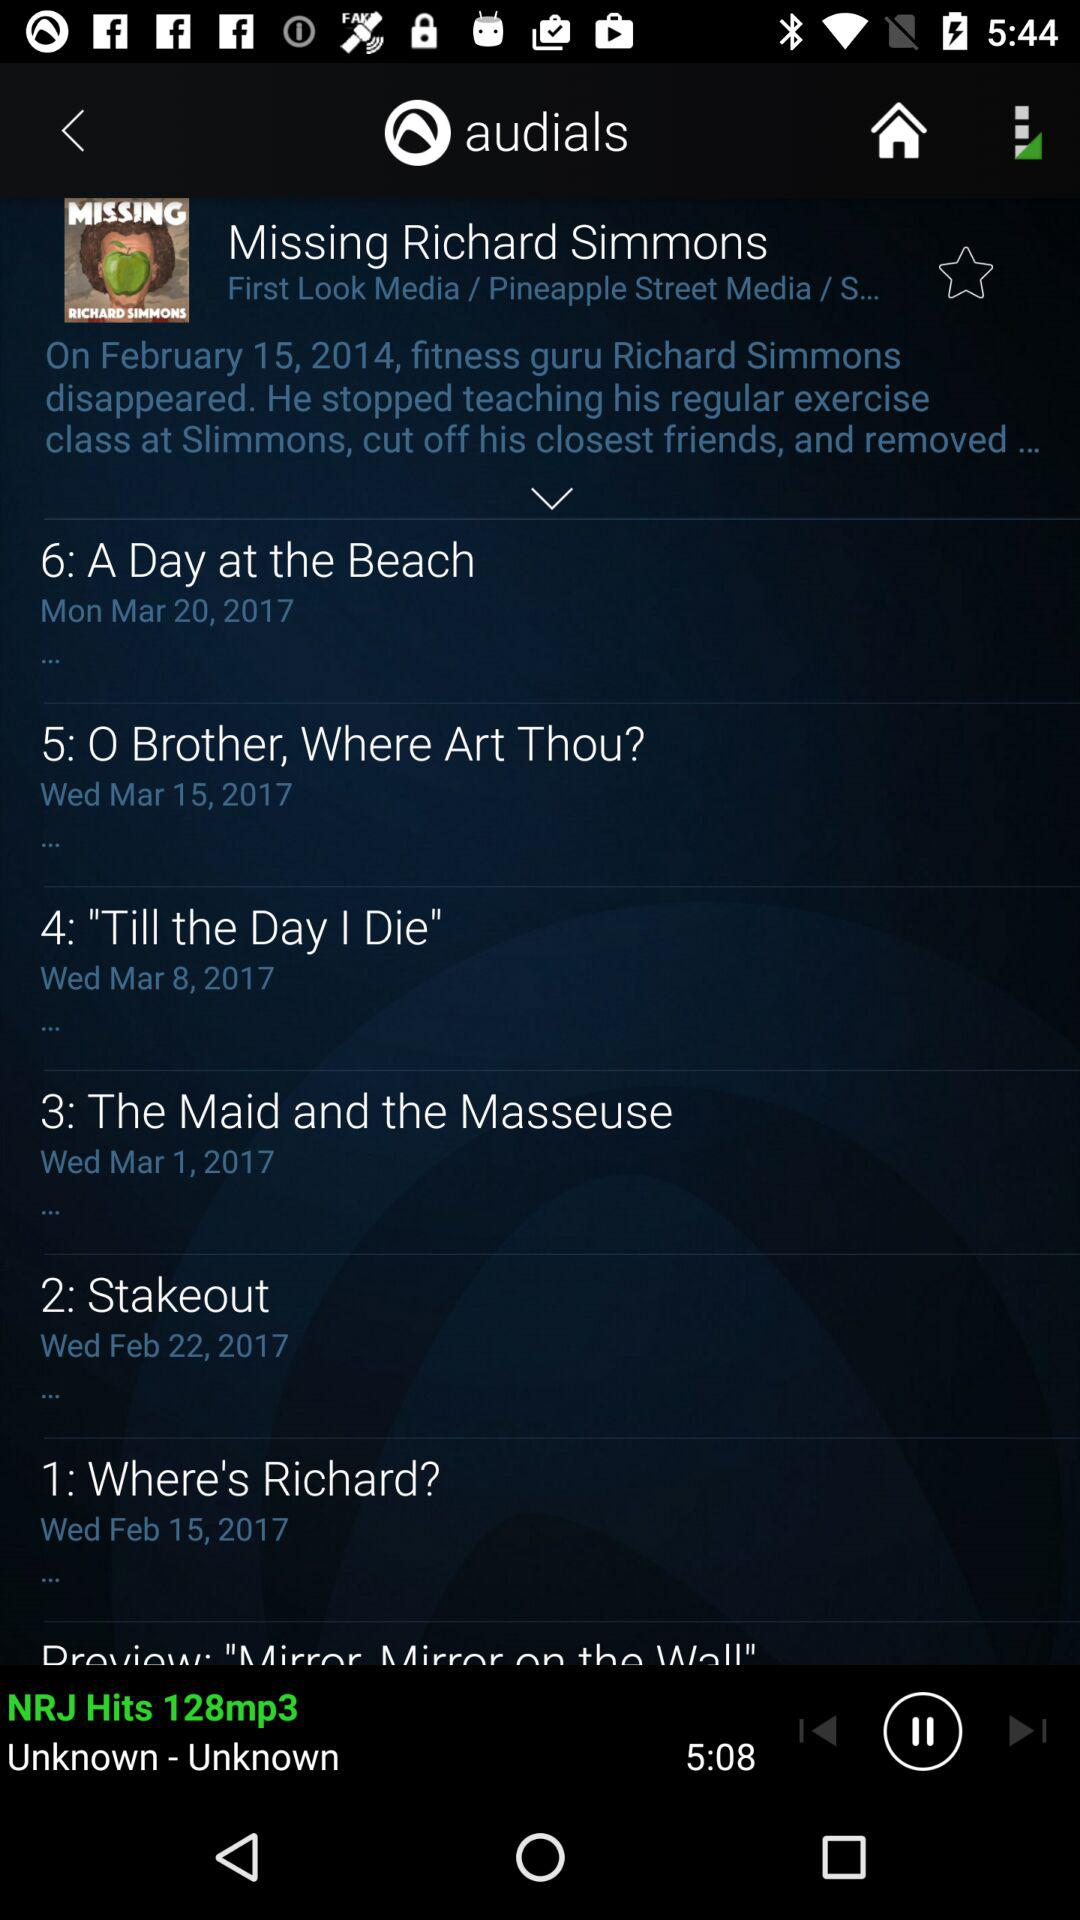What is the date for "A Day at the Beach"? The date for "A Day at the Beach" is Monday, March 20, 2017. 